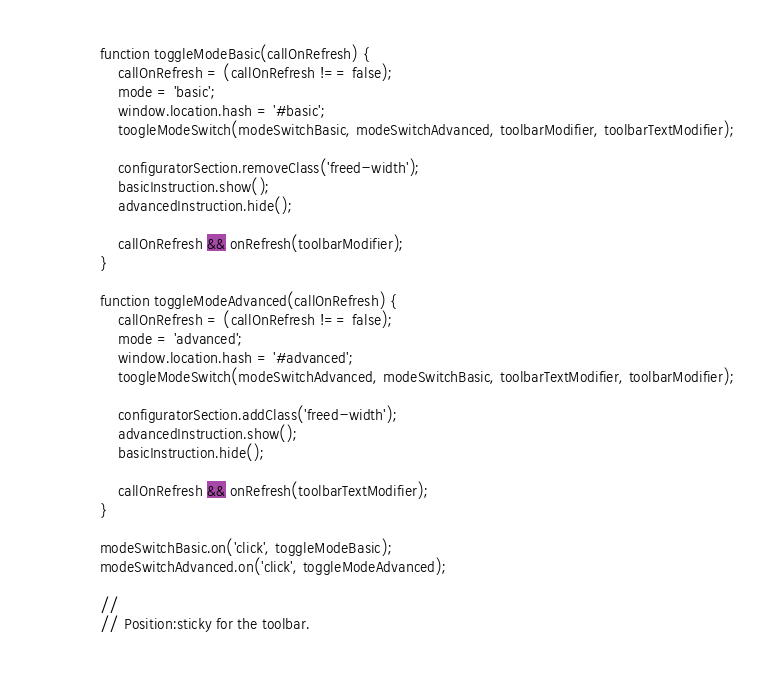<code> <loc_0><loc_0><loc_500><loc_500><_HTML_>
			function toggleModeBasic(callOnRefresh) {
				callOnRefresh = (callOnRefresh !== false);
				mode = 'basic';
				window.location.hash = '#basic';
				toogleModeSwitch(modeSwitchBasic, modeSwitchAdvanced, toolbarModifier, toolbarTextModifier);

				configuratorSection.removeClass('freed-width');
				basicInstruction.show();
				advancedInstruction.hide();

				callOnRefresh && onRefresh(toolbarModifier);
			}

			function toggleModeAdvanced(callOnRefresh) {
				callOnRefresh = (callOnRefresh !== false);
				mode = 'advanced';
				window.location.hash = '#advanced';
				toogleModeSwitch(modeSwitchAdvanced, modeSwitchBasic, toolbarTextModifier, toolbarModifier);

				configuratorSection.addClass('freed-width');
				advancedInstruction.show();
				basicInstruction.hide();

				callOnRefresh && onRefresh(toolbarTextModifier);
			}

			modeSwitchBasic.on('click', toggleModeBasic);
			modeSwitchAdvanced.on('click', toggleModeAdvanced);

			//
			// Position:sticky for the toolbar.</code> 